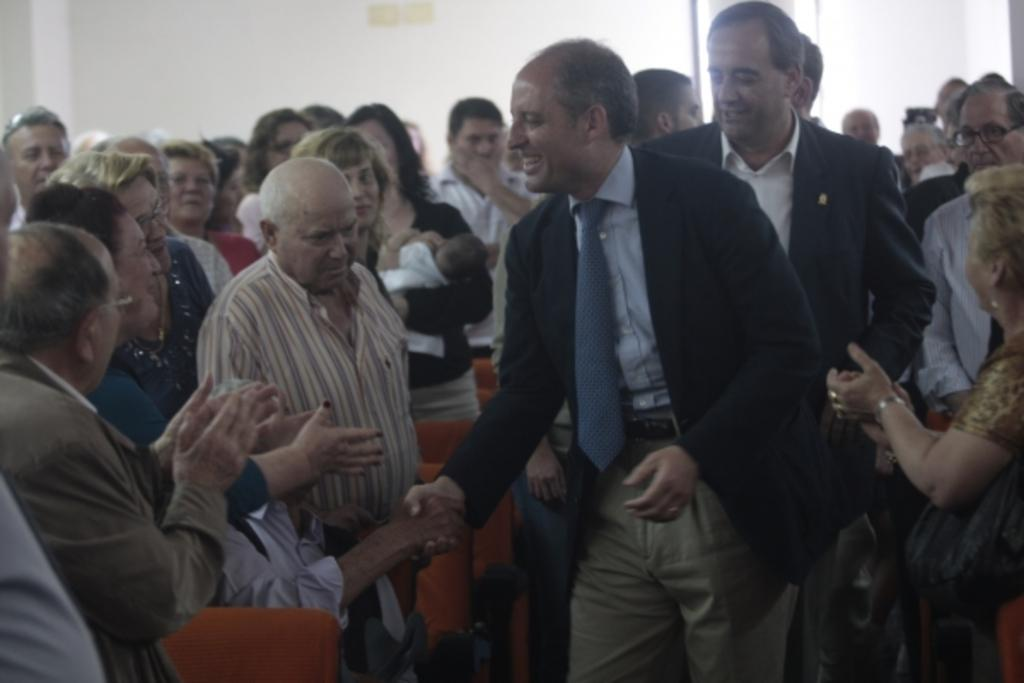What is happening in the foreground of the image? Two persons are shaking hands in the foreground. Can you describe the group of people in the image? There is a group of people in the image, but the exact number or their activities cannot be determined from the provided facts. What is visible in the background of the image? There is a wall in the background of the image. What type of bone is visible in the image? There is no bone present in the image; it features a group of people and a wall in the background. 